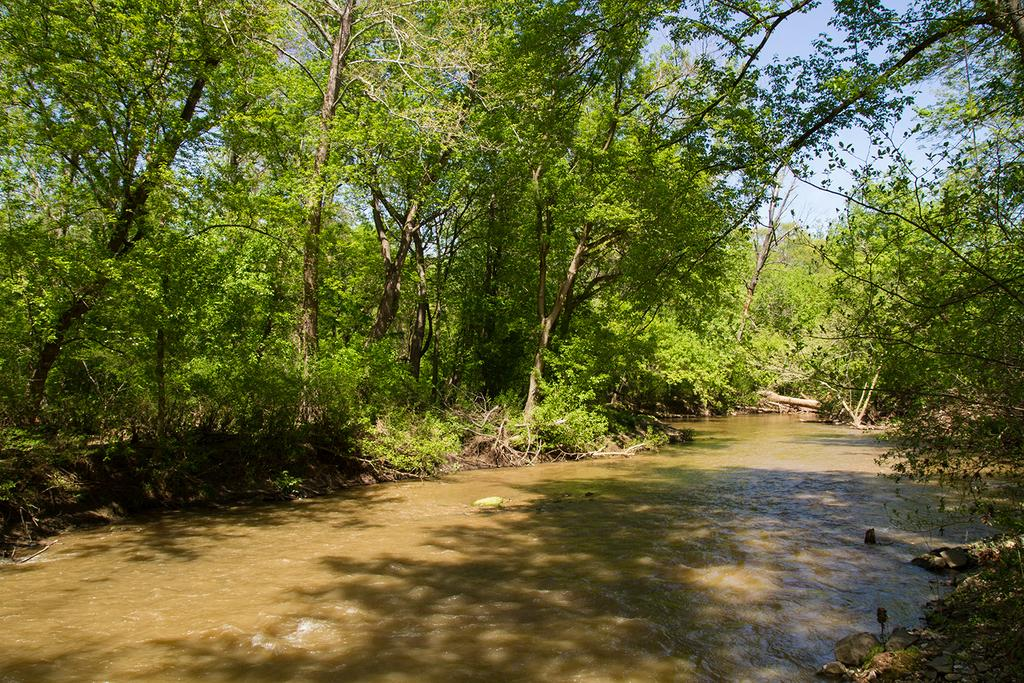What is happening at the bottom of the image? Water is flowing at the bottom of the image. What type of government is depicted in the image? There is no depiction of a government in the image; it features flowing water and a background with trees and the sky. 